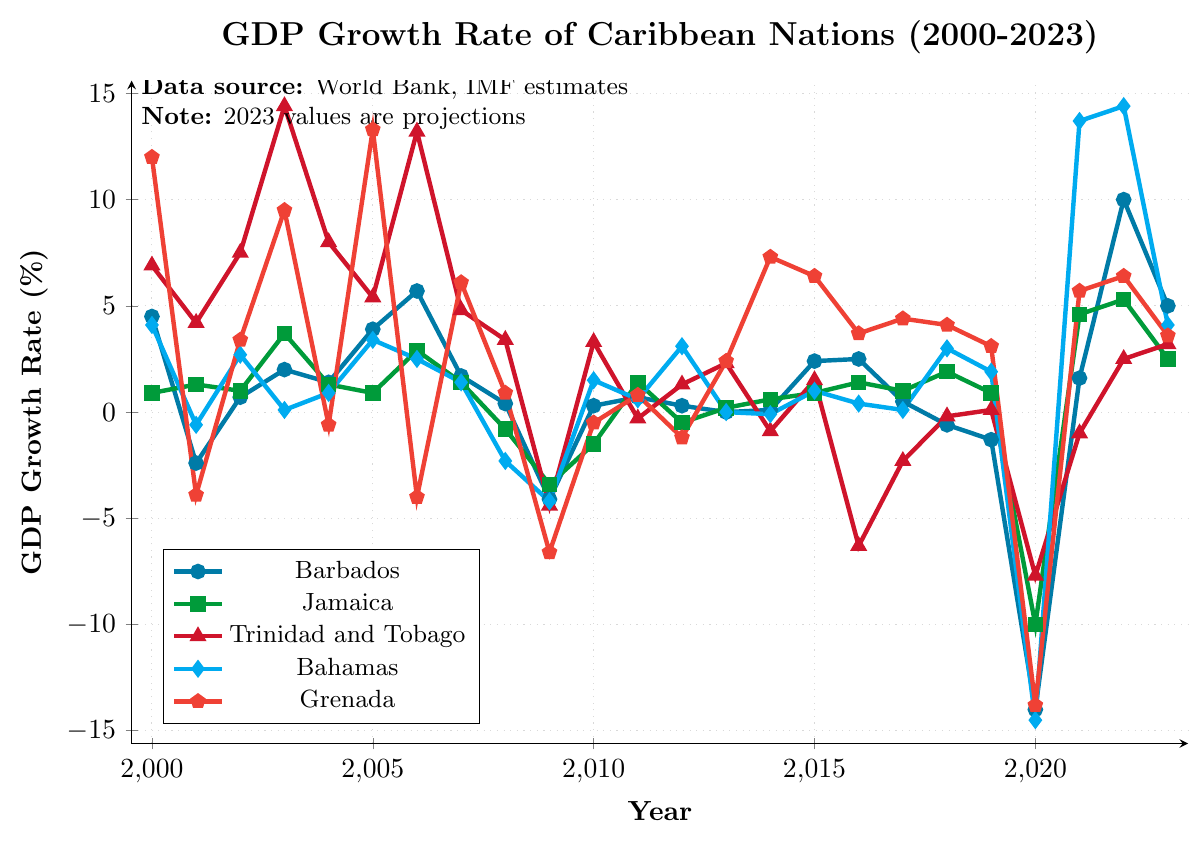What was the GDP growth rate of Barbados in 2020? Find the point corresponding to the year 2020 on the x-axis and observe the GDP growth rate value for Barbados.
Answer: -14% In which year did Trinidad and Tobago experience the highest GDP growth rate, and what was it? Identify the highest point on Trinidad and Tobago's line and note the corresponding year and growth rate.
Answer: 2003, 14.4% Compare the GDP growth rates of Barbados and Jamaica in 2023, which country had a higher rate, and by how much? Locate the GDP growth rates for Barbados and Jamaica in 2023, then subtract Jamaica's rate from Barbados's rate.
Answer: Barbados by 2.5% How many countries had negative GDP growth rates in 2009, and which ones were they? Observe all the lines in 2009 and count the lines that fall below the zero mark on the y-axis.
Answer: 5 countries: Barbados, Jamaica, Trinidad and Tobago, Bahamas, Grenada Which country had the most volatile GDP growth rate from 2000 to 2023, based on the variability in the line's height? Compare the fluctuation ranges of each country's line to determine which one shows the highest variability.
Answer: Grenada During which years did Barbados experience consecutive negative GDP growth rates? Analyze the line for Barbados and identify spans where the growth rate is consecutively below zero.
Answer: 2008-2010, 2018-2019 In 2022, which country had the highest GDP growth rate and what was it? Identify the highest point on the lines corresponding to the year 2022 and note the country and growth rate.
Answer: Bahamas, 14.4% Calculate the average GDP growth rate of Jamaica between 2020 and 2023. Sum up the GDP growth rates of Jamaica from 2020 to 2023 and divide by the number of years (4).
Answer: (-10 + 4.6 + 5.3 + 2.5) / 4 = 0.6% How did the GDP growth rate of Barbados in 2001 compare with its GDP growth rate in 2002? Observe the GDP growth rates of Barbados in 2001 and 2002, then compare them to see if it increased or decreased.
Answer: Increased by 3.1% In what year did all countries experience negative GDP growth rates? Look for a year where all lines are below the zero mark on the y-axis.
Answer: 2020 